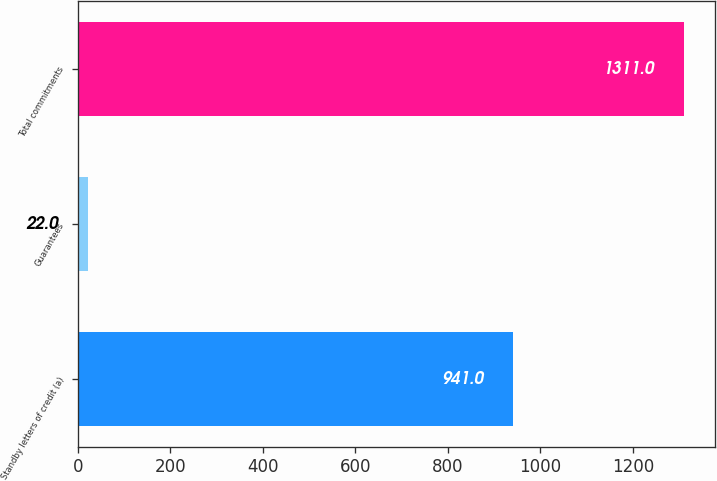<chart> <loc_0><loc_0><loc_500><loc_500><bar_chart><fcel>Standby letters of credit (a)<fcel>Guarantees<fcel>Total commitments<nl><fcel>941<fcel>22<fcel>1311<nl></chart> 